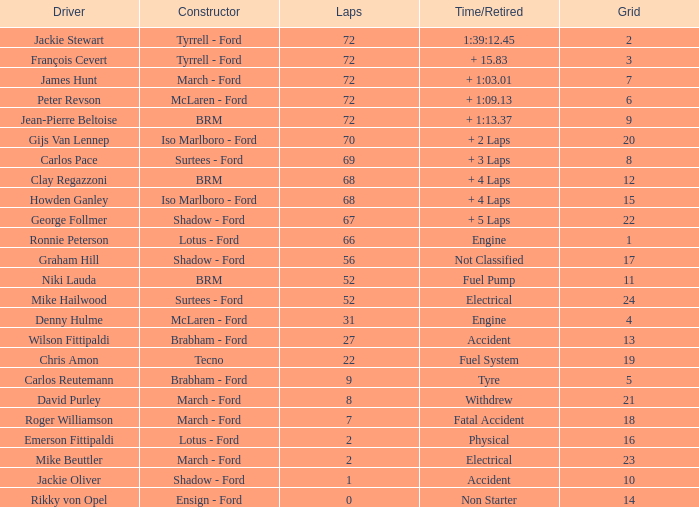Help me parse the entirety of this table. {'header': ['Driver', 'Constructor', 'Laps', 'Time/Retired', 'Grid'], 'rows': [['Jackie Stewart', 'Tyrrell - Ford', '72', '1:39:12.45', '2'], ['François Cevert', 'Tyrrell - Ford', '72', '+ 15.83', '3'], ['James Hunt', 'March - Ford', '72', '+ 1:03.01', '7'], ['Peter Revson', 'McLaren - Ford', '72', '+ 1:09.13', '6'], ['Jean-Pierre Beltoise', 'BRM', '72', '+ 1:13.37', '9'], ['Gijs Van Lennep', 'Iso Marlboro - Ford', '70', '+ 2 Laps', '20'], ['Carlos Pace', 'Surtees - Ford', '69', '+ 3 Laps', '8'], ['Clay Regazzoni', 'BRM', '68', '+ 4 Laps', '12'], ['Howden Ganley', 'Iso Marlboro - Ford', '68', '+ 4 Laps', '15'], ['George Follmer', 'Shadow - Ford', '67', '+ 5 Laps', '22'], ['Ronnie Peterson', 'Lotus - Ford', '66', 'Engine', '1'], ['Graham Hill', 'Shadow - Ford', '56', 'Not Classified', '17'], ['Niki Lauda', 'BRM', '52', 'Fuel Pump', '11'], ['Mike Hailwood', 'Surtees - Ford', '52', 'Electrical', '24'], ['Denny Hulme', 'McLaren - Ford', '31', 'Engine', '4'], ['Wilson Fittipaldi', 'Brabham - Ford', '27', 'Accident', '13'], ['Chris Amon', 'Tecno', '22', 'Fuel System', '19'], ['Carlos Reutemann', 'Brabham - Ford', '9', 'Tyre', '5'], ['David Purley', 'March - Ford', '8', 'Withdrew', '21'], ['Roger Williamson', 'March - Ford', '7', 'Fatal Accident', '18'], ['Emerson Fittipaldi', 'Lotus - Ford', '2', 'Physical', '16'], ['Mike Beuttler', 'March - Ford', '2', 'Electrical', '23'], ['Jackie Oliver', 'Shadow - Ford', '1', 'Accident', '10'], ['Rikky von Opel', 'Ensign - Ford', '0', 'Non Starter', '14']]} What is the top grid that roger williamson lapped less than 7? None. 